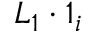Convert formula to latex. <formula><loc_0><loc_0><loc_500><loc_500>L _ { 1 } \cdot 1 _ { i }</formula> 